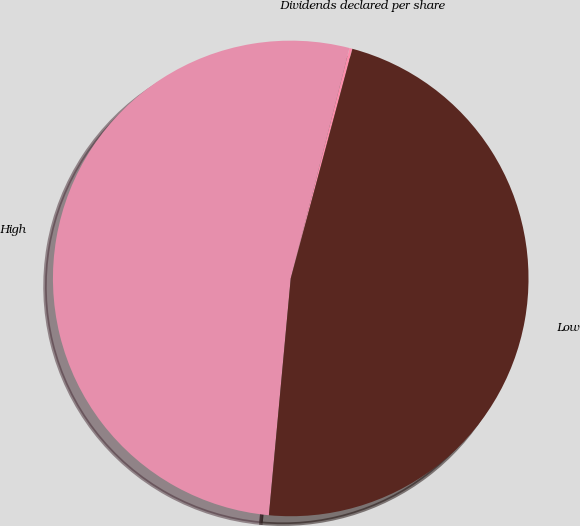Convert chart to OTSL. <chart><loc_0><loc_0><loc_500><loc_500><pie_chart><fcel>Dividends declared per share<fcel>High<fcel>Low<nl><fcel>0.2%<fcel>52.51%<fcel>47.29%<nl></chart> 